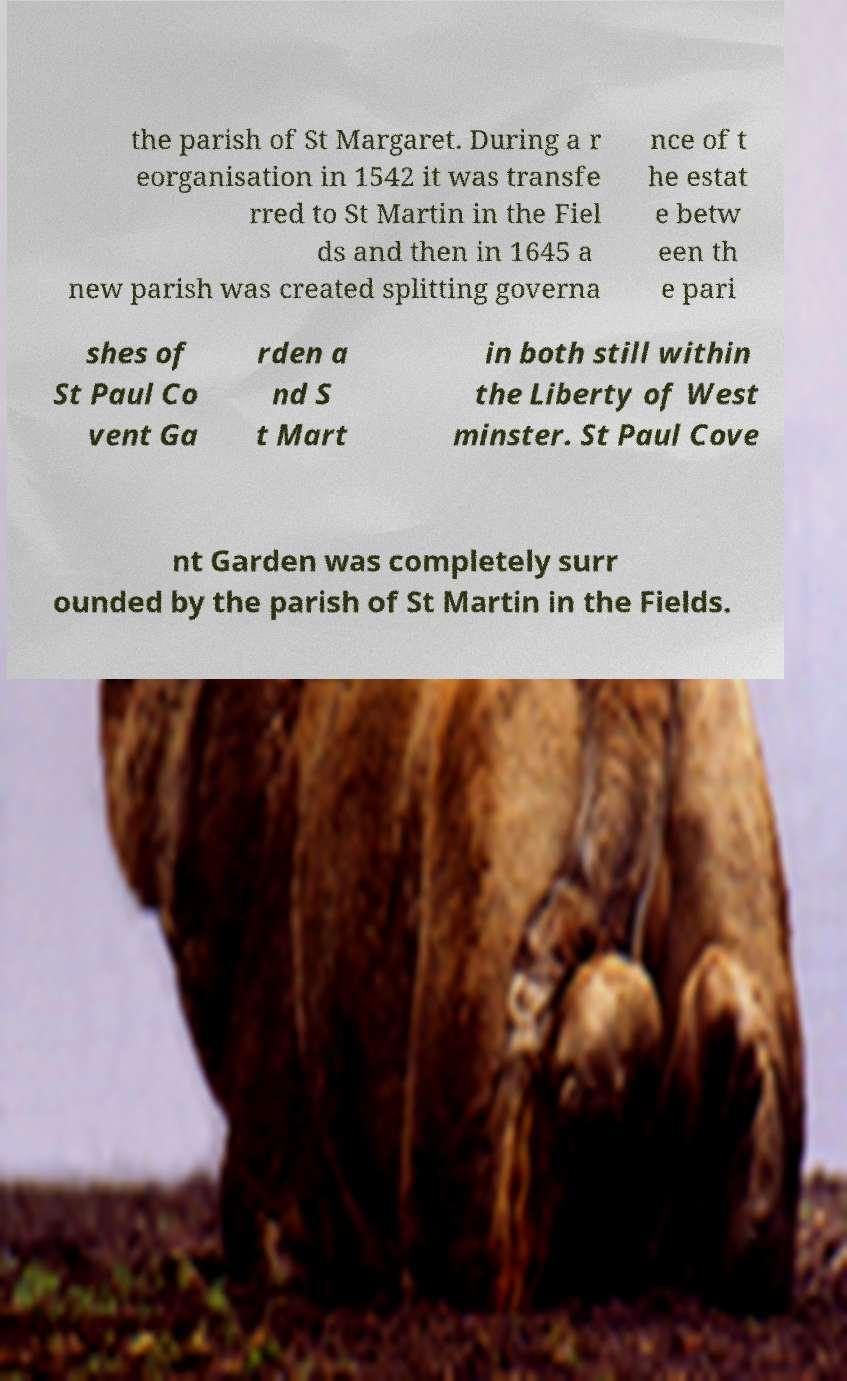Could you assist in decoding the text presented in this image and type it out clearly? the parish of St Margaret. During a r eorganisation in 1542 it was transfe rred to St Martin in the Fiel ds and then in 1645 a new parish was created splitting governa nce of t he estat e betw een th e pari shes of St Paul Co vent Ga rden a nd S t Mart in both still within the Liberty of West minster. St Paul Cove nt Garden was completely surr ounded by the parish of St Martin in the Fields. 